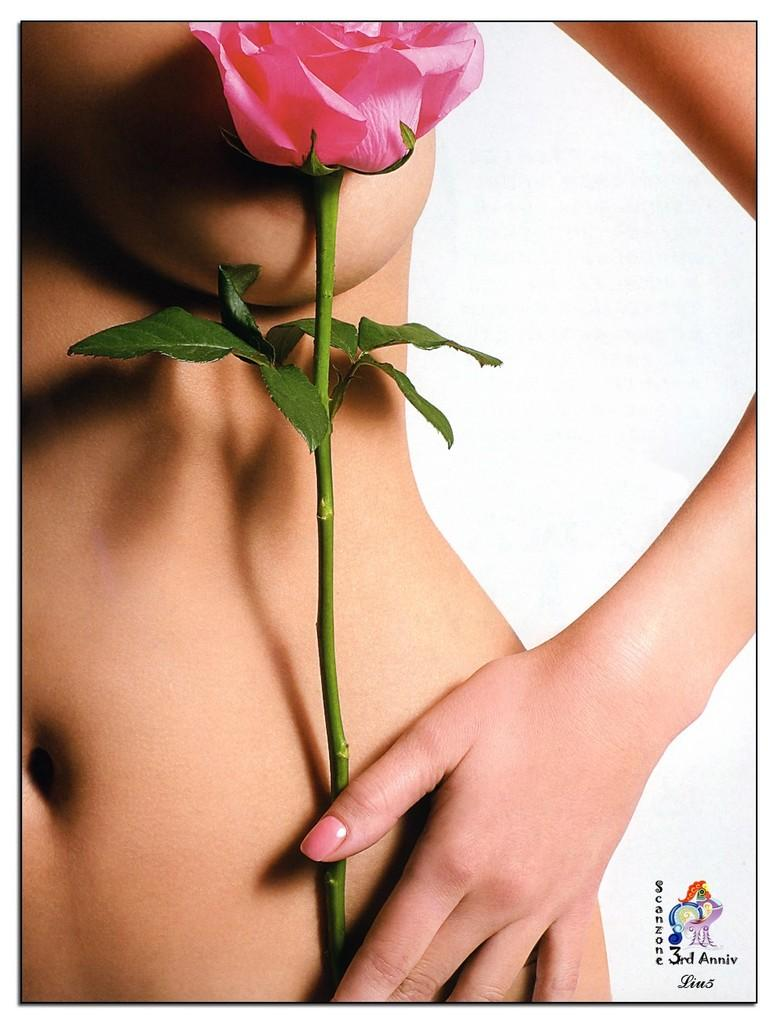Who is present in the image? There is a woman in the image. What is the woman holding in the image? The woman is holding a plant. Can you describe the plant in the image? The plant has rose flowers and green leaves. Where is the watermark located in the image? The watermark is in the bottom left corner of the image. What is the color of the background in the image? The background of the image is white. Can you hear the rhythm of the goat's hooves in the image? There is no goat present in the image, so it is not possible to hear any rhythm of hooves. 